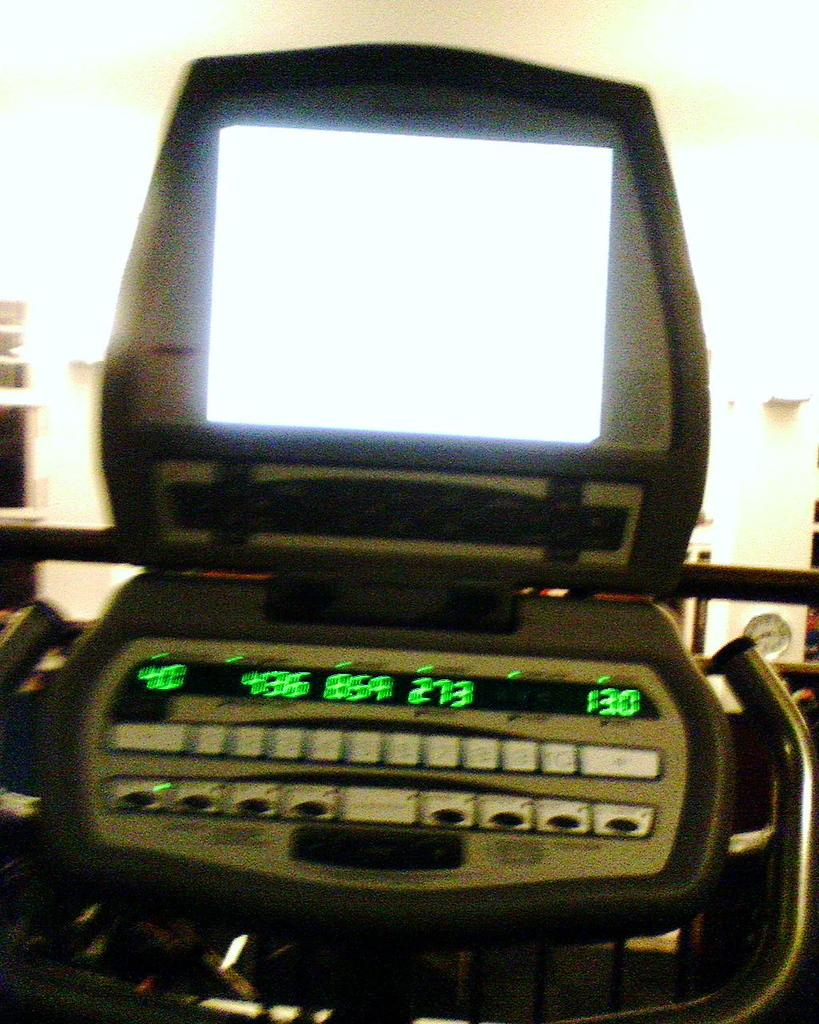What type of object can be seen in the image? There is an electronic device in the image. How many ladybugs are crawling on the electronic device in the image? There are no ladybugs present in the image; it only features an electronic device. 